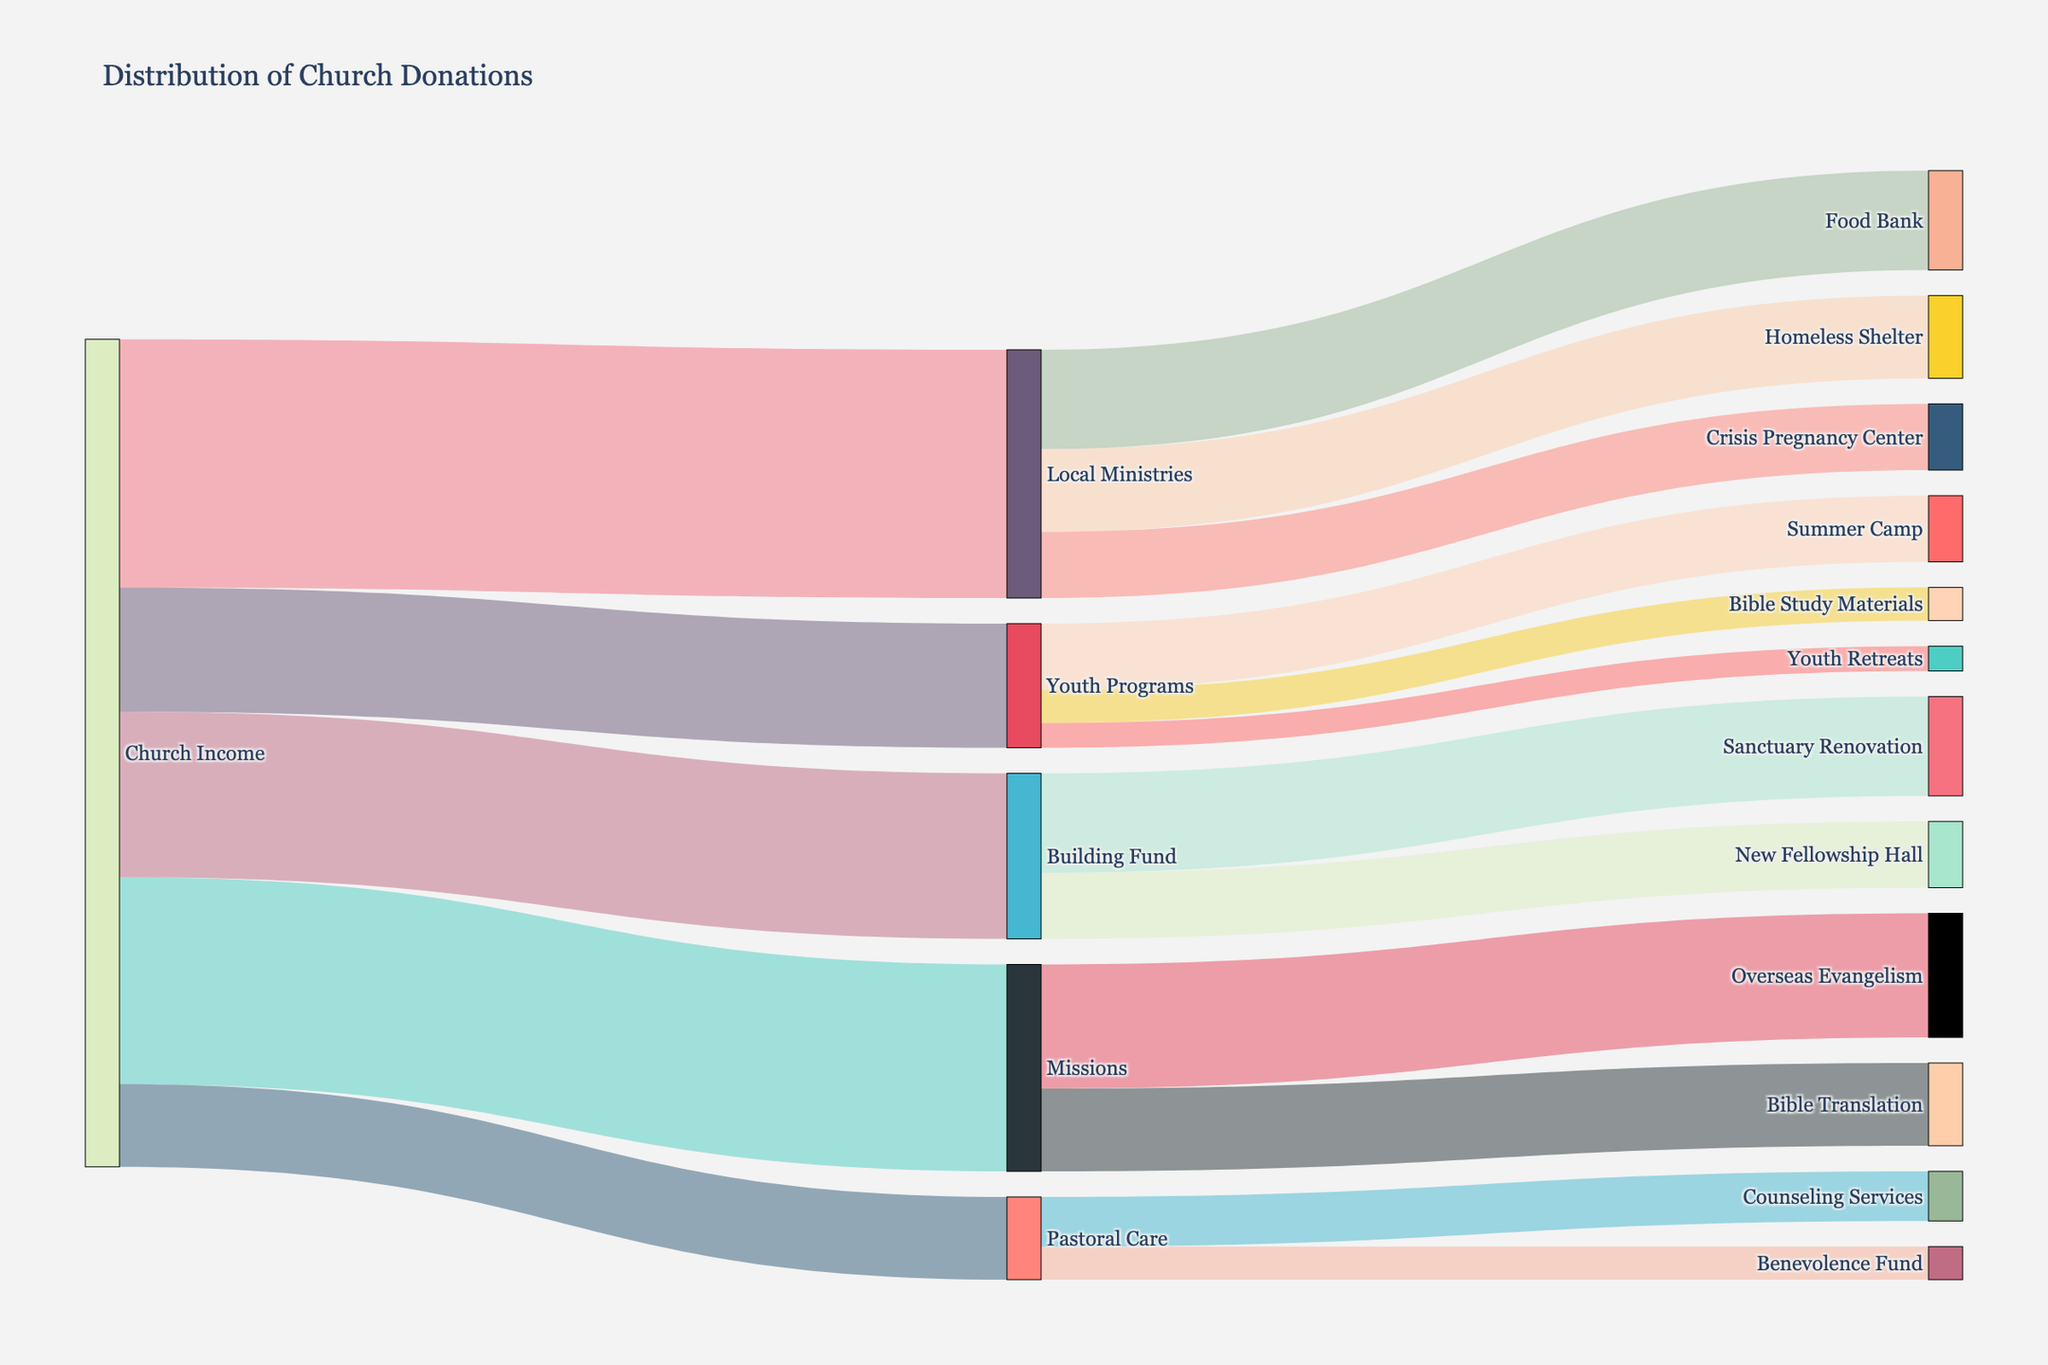What is the total donation amount directed towards Local Ministries? Sum all the donations directed towards Local Ministries: Food Bank ($12,000) + Homeless Shelter ($10,000) + Crisis Pregnancy Center ($8,000) = $30,000
Answer: $30,000 Which cause received the highest donation amount from Youth Programs? Among the Youth Programs, compare the donation amounts: Summer Camp ($8,000), Bible Study Materials ($4,000), Youth Retreats ($3,000). The highest donation is for Summer Camp.
Answer: Summer Camp Between the Building Fund and the Pastoral Care, which received more donations from Church Income? Compare the donations from Church Income: Building Fund ($20,000) and Pastoral Care ($10,000). The Building Fund received more donations.
Answer: Building Fund How much is donated to Bible Translation through Missions? Identify the donation under Missions directed towards Bible Translation: $10,000
Answer: $10,000 What is the combined donation amount directed to Sanctuary Renovation and New Fellowship Hall from Building Fund? Sum the donation amounts to Sanctuary Renovation ($12,000) and New Fellowship Hall ($8,000): $12,000 + $8,000 = $20,000
Answer: $20,000 What is the total amount of donations handled by the Church Income across all categories? Sum all donations managed by Church Income: Local Ministries ($30,000) + Missions ($25,000) + Building Fund ($20,000) + Youth Programs ($15,000) + Pastoral Care ($10,000) = $100,000
Answer: $100,000 Compare the donations to Overseas Evangelism and Bible Translation under Missions. Which received more? Compare the donation amounts: Overseas Evangelism ($15,000) and Bible Translation ($10,000). Overseas Evangelism received more.
Answer: Overseas Evangelism What is the percentage of the total Church Income used for Youth Programs? Calculate the percentage: (Youth Programs $15,000 / Total Church Income $100,000) * 100% = 15%
Answer: 15% Which specific cause under Local Ministries received the least donation? Compare the donations under Local Ministries: Food Bank ($12,000), Homeless Shelter ($10,000), Crisis Pregnancy Center ($8,000). Crisis Pregnancy Center received the least.
Answer: Crisis Pregnancy Center What is the total donation directed towards Pastoral Care's Counseling Services and Benevolence Fund? Sum the donations to Counseling Services ($6,000) and Benevolence Fund ($4,000): $6,000 + $4,000 = $10,000
Answer: $10,000 